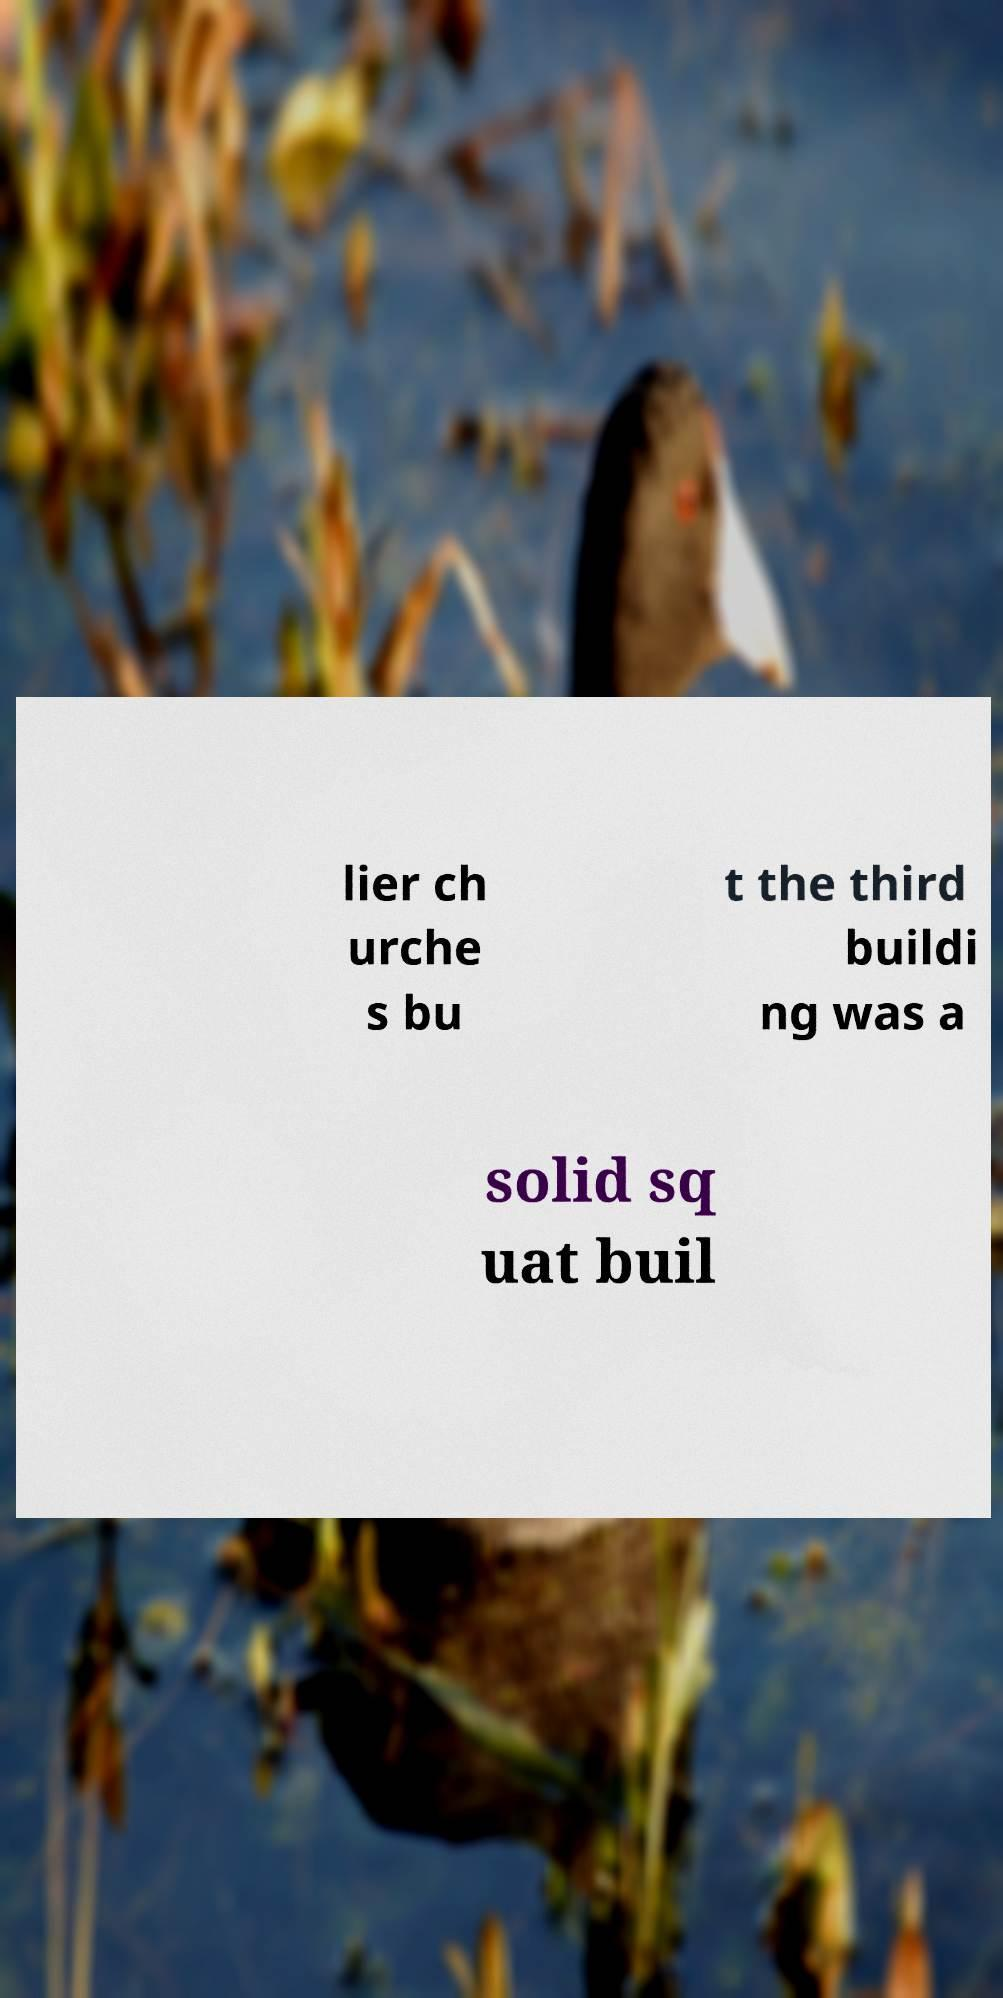I need the written content from this picture converted into text. Can you do that? lier ch urche s bu t the third buildi ng was a solid sq uat buil 